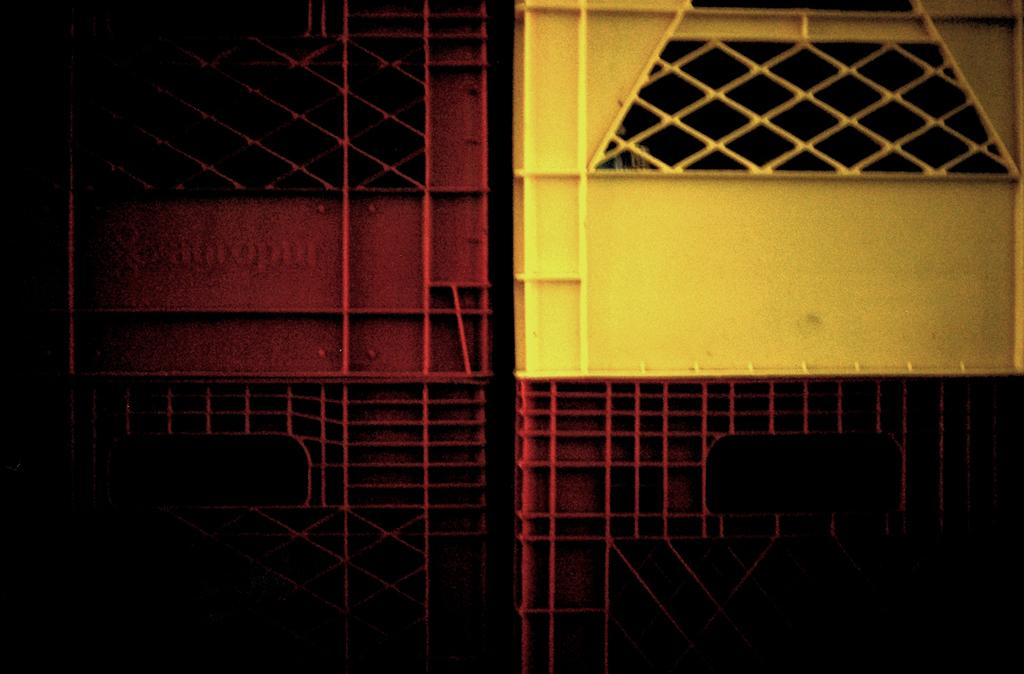What is the main object in the image? There is a gate in the image. What colors are used for the gate? The gate has a yellow and red color. Can you describe the lighting on the left side of the image? The image on the left side appears to be dark. Is there a veil covering the gate in the image? No, there is no veil present in the image. How many pears can be seen hanging from the gate in the image? There are no pears visible in the image. 